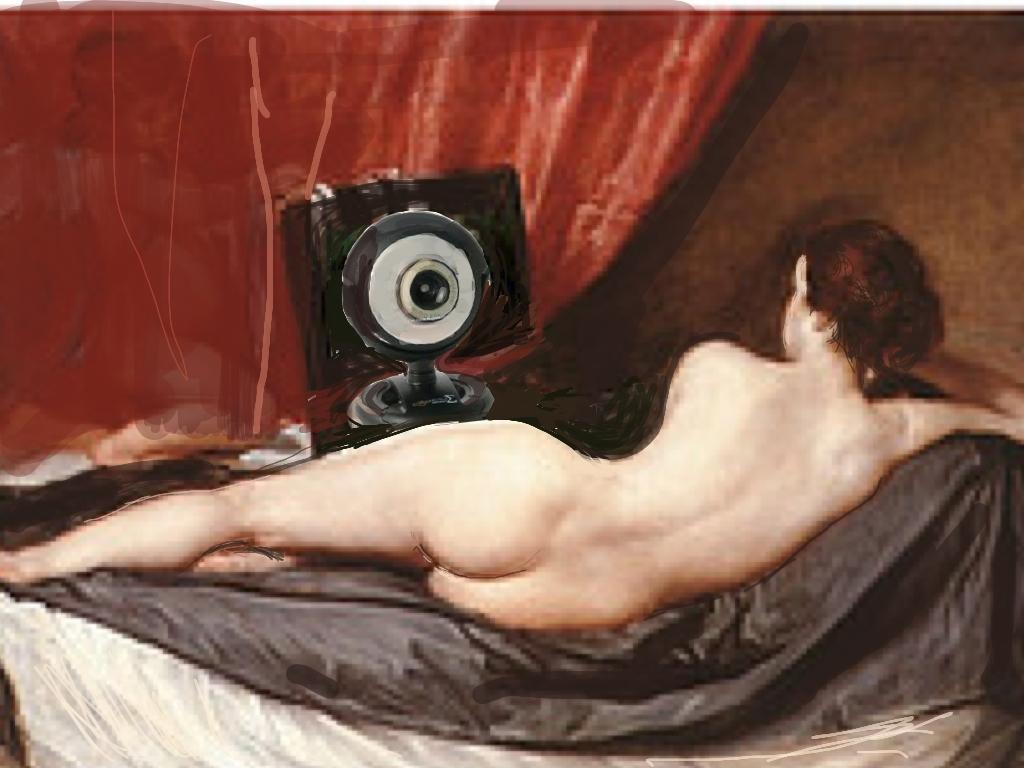What is depicted in the painting in the image? There is a painting of a woman in the image. What is the woman doing in the painting? The woman is lying on a cloth in the painting. What other object can be seen in the image? There is a camera visible in the background of the image. What type of art can be seen on the moon in the image? There is no moon present in the image, and therefore no art can be seen on it. 